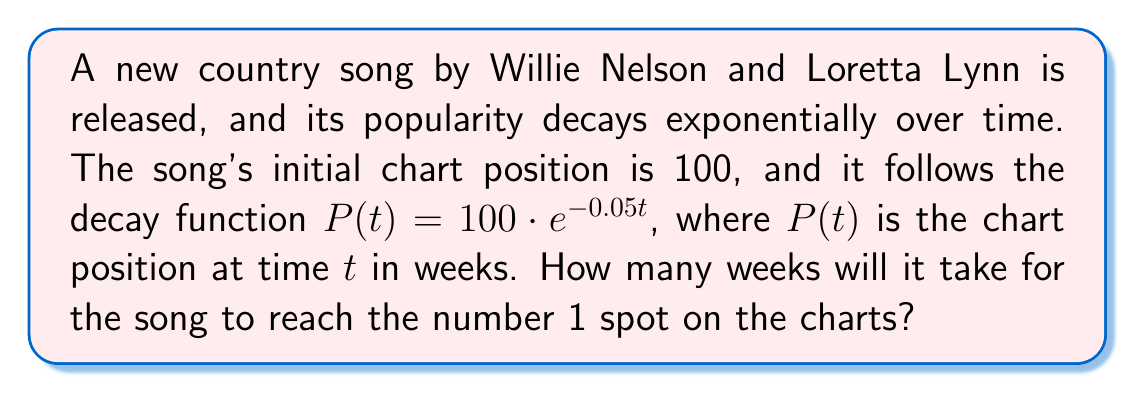Can you answer this question? Let's approach this step-by-step:

1) We need to find $t$ when $P(t) = 1$ (the #1 spot on the charts).

2) We can set up the equation:
   $1 = 100 \cdot e^{-0.05t}$

3) Divide both sides by 100:
   $\frac{1}{100} = e^{-0.05t}$

4) Take the natural log of both sides:
   $\ln(\frac{1}{100}) = \ln(e^{-0.05t})$

5) Simplify the right side using the properties of logarithms:
   $\ln(\frac{1}{100}) = -0.05t$

6) Simplify the left side:
   $-4.605 = -0.05t$

7) Divide both sides by -0.05:
   $\frac{-4.605}{-0.05} = t$

8) Simplify:
   $92.1 = t$

9) Since we're dealing with weeks, we round up to the nearest whole number:
   $t = 93$ weeks
Answer: 93 weeks 